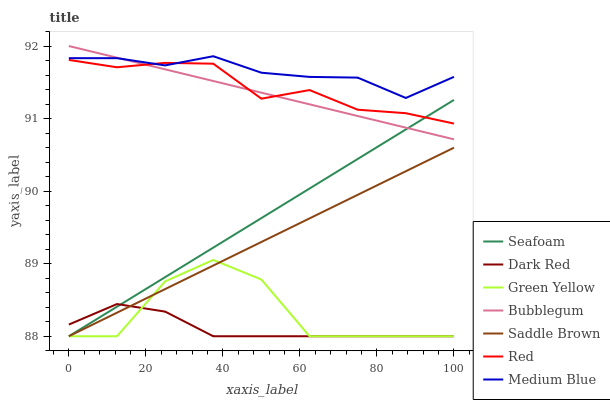Does Dark Red have the minimum area under the curve?
Answer yes or no. Yes. Does Medium Blue have the maximum area under the curve?
Answer yes or no. Yes. Does Seafoam have the minimum area under the curve?
Answer yes or no. No. Does Seafoam have the maximum area under the curve?
Answer yes or no. No. Is Bubblegum the smoothest?
Answer yes or no. Yes. Is Green Yellow the roughest?
Answer yes or no. Yes. Is Medium Blue the smoothest?
Answer yes or no. No. Is Medium Blue the roughest?
Answer yes or no. No. Does Dark Red have the lowest value?
Answer yes or no. Yes. Does Medium Blue have the lowest value?
Answer yes or no. No. Does Bubblegum have the highest value?
Answer yes or no. Yes. Does Medium Blue have the highest value?
Answer yes or no. No. Is Saddle Brown less than Red?
Answer yes or no. Yes. Is Red greater than Green Yellow?
Answer yes or no. Yes. Does Seafoam intersect Saddle Brown?
Answer yes or no. Yes. Is Seafoam less than Saddle Brown?
Answer yes or no. No. Is Seafoam greater than Saddle Brown?
Answer yes or no. No. Does Saddle Brown intersect Red?
Answer yes or no. No. 